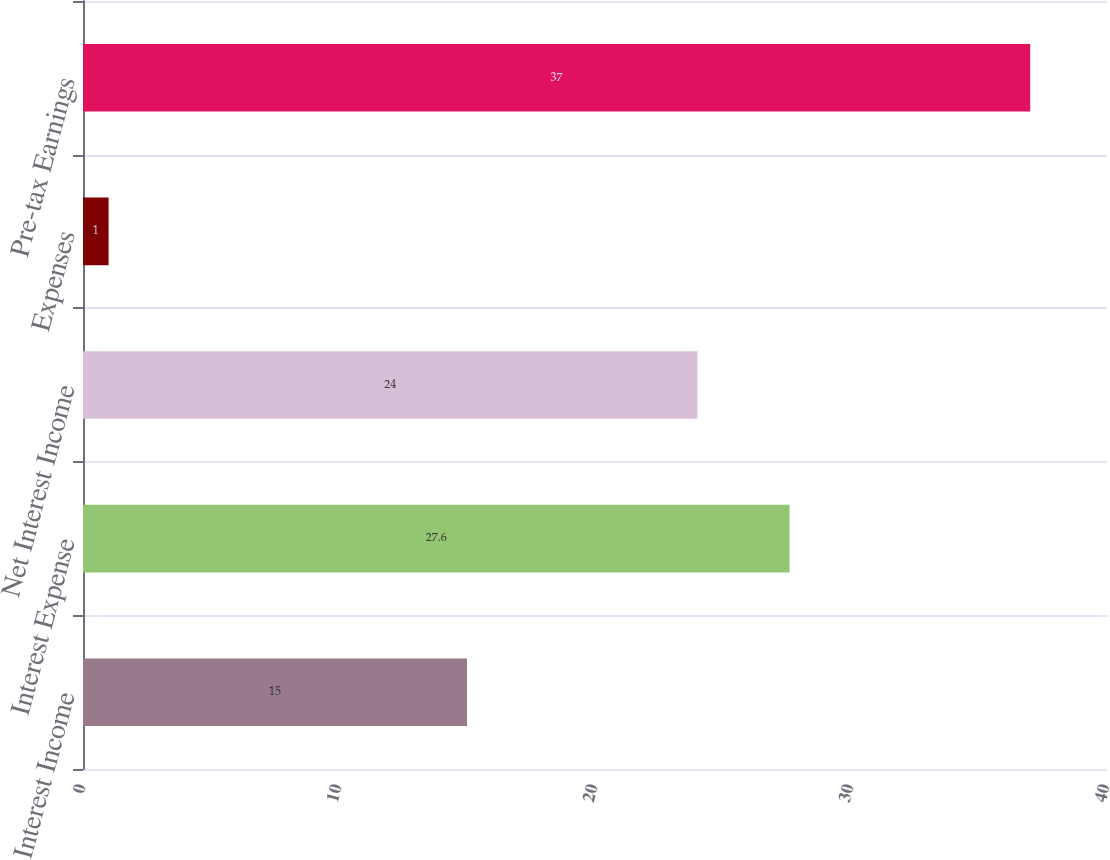Convert chart. <chart><loc_0><loc_0><loc_500><loc_500><bar_chart><fcel>Interest Income<fcel>Interest Expense<fcel>Net Interest Income<fcel>Expenses<fcel>Pre-tax Earnings<nl><fcel>15<fcel>27.6<fcel>24<fcel>1<fcel>37<nl></chart> 